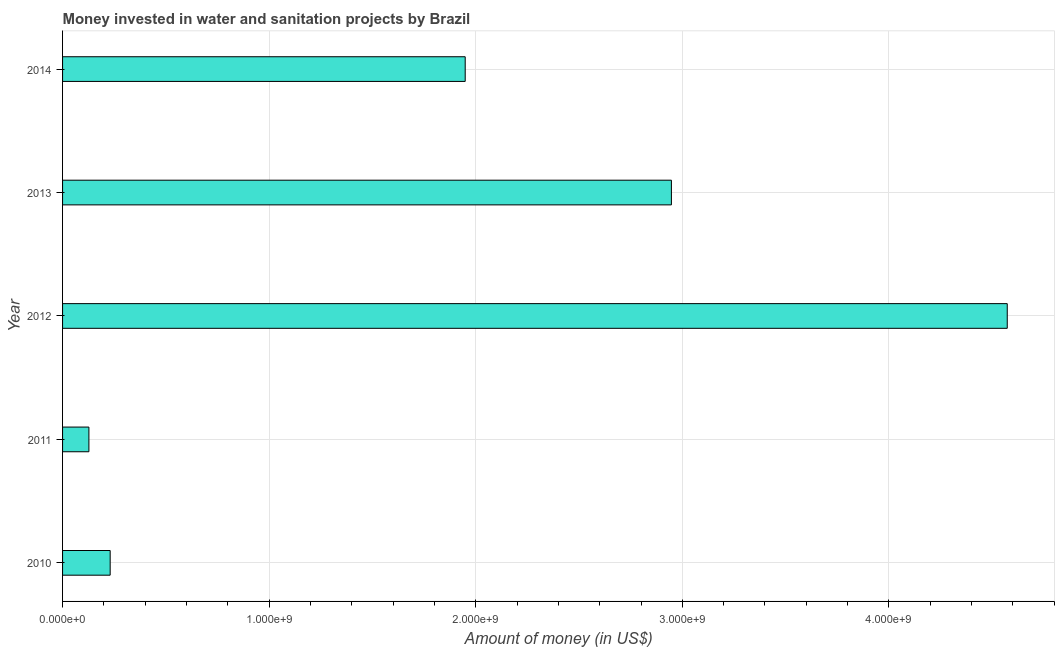Does the graph contain grids?
Provide a succinct answer. Yes. What is the title of the graph?
Ensure brevity in your answer.  Money invested in water and sanitation projects by Brazil. What is the label or title of the X-axis?
Your answer should be very brief. Amount of money (in US$). What is the investment in 2013?
Offer a very short reply. 2.95e+09. Across all years, what is the maximum investment?
Offer a terse response. 4.57e+09. Across all years, what is the minimum investment?
Offer a terse response. 1.28e+08. What is the sum of the investment?
Give a very brief answer. 9.83e+09. What is the difference between the investment in 2010 and 2013?
Provide a short and direct response. -2.72e+09. What is the average investment per year?
Make the answer very short. 1.97e+09. What is the median investment?
Offer a terse response. 1.95e+09. In how many years, is the investment greater than 4400000000 US$?
Your answer should be very brief. 1. Do a majority of the years between 2014 and 2010 (inclusive) have investment greater than 4400000000 US$?
Your answer should be very brief. Yes. What is the ratio of the investment in 2012 to that in 2013?
Keep it short and to the point. 1.55. What is the difference between the highest and the second highest investment?
Your answer should be very brief. 1.63e+09. Is the sum of the investment in 2011 and 2013 greater than the maximum investment across all years?
Give a very brief answer. No. What is the difference between the highest and the lowest investment?
Ensure brevity in your answer.  4.45e+09. In how many years, is the investment greater than the average investment taken over all years?
Provide a short and direct response. 2. How many bars are there?
Keep it short and to the point. 5. Are all the bars in the graph horizontal?
Provide a succinct answer. Yes. How many years are there in the graph?
Keep it short and to the point. 5. What is the Amount of money (in US$) in 2010?
Your answer should be very brief. 2.30e+08. What is the Amount of money (in US$) in 2011?
Provide a short and direct response. 1.28e+08. What is the Amount of money (in US$) in 2012?
Your answer should be compact. 4.57e+09. What is the Amount of money (in US$) in 2013?
Make the answer very short. 2.95e+09. What is the Amount of money (in US$) in 2014?
Provide a short and direct response. 1.95e+09. What is the difference between the Amount of money (in US$) in 2010 and 2011?
Give a very brief answer. 1.03e+08. What is the difference between the Amount of money (in US$) in 2010 and 2012?
Your answer should be compact. -4.34e+09. What is the difference between the Amount of money (in US$) in 2010 and 2013?
Your response must be concise. -2.72e+09. What is the difference between the Amount of money (in US$) in 2010 and 2014?
Your answer should be compact. -1.72e+09. What is the difference between the Amount of money (in US$) in 2011 and 2012?
Provide a succinct answer. -4.45e+09. What is the difference between the Amount of money (in US$) in 2011 and 2013?
Provide a short and direct response. -2.82e+09. What is the difference between the Amount of money (in US$) in 2011 and 2014?
Your response must be concise. -1.82e+09. What is the difference between the Amount of money (in US$) in 2012 and 2013?
Make the answer very short. 1.63e+09. What is the difference between the Amount of money (in US$) in 2012 and 2014?
Your answer should be very brief. 2.62e+09. What is the difference between the Amount of money (in US$) in 2013 and 2014?
Provide a succinct answer. 9.98e+08. What is the ratio of the Amount of money (in US$) in 2010 to that in 2011?
Your answer should be very brief. 1.81. What is the ratio of the Amount of money (in US$) in 2010 to that in 2012?
Your answer should be very brief. 0.05. What is the ratio of the Amount of money (in US$) in 2010 to that in 2013?
Provide a short and direct response. 0.08. What is the ratio of the Amount of money (in US$) in 2010 to that in 2014?
Offer a terse response. 0.12. What is the ratio of the Amount of money (in US$) in 2011 to that in 2012?
Your answer should be very brief. 0.03. What is the ratio of the Amount of money (in US$) in 2011 to that in 2013?
Provide a short and direct response. 0.04. What is the ratio of the Amount of money (in US$) in 2011 to that in 2014?
Provide a short and direct response. 0.07. What is the ratio of the Amount of money (in US$) in 2012 to that in 2013?
Provide a short and direct response. 1.55. What is the ratio of the Amount of money (in US$) in 2012 to that in 2014?
Your response must be concise. 2.35. What is the ratio of the Amount of money (in US$) in 2013 to that in 2014?
Your answer should be compact. 1.51. 